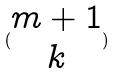Convert formula to latex. <formula><loc_0><loc_0><loc_500><loc_500>( \begin{matrix} m + 1 \\ k \end{matrix} )</formula> 